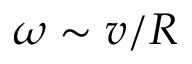<formula> <loc_0><loc_0><loc_500><loc_500>\omega \sim v / R</formula> 